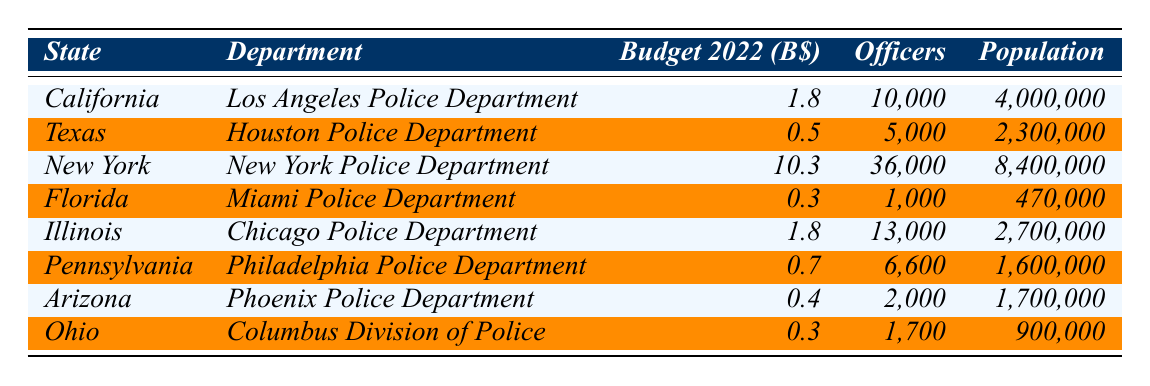What is the budget allocation for the New York Police Department? The budget allocation is directly stated in the table under "Budget 2022" for the New York Police Department, which is 10.3 billion dollars.
Answer: 10.3 billion dollars How many officers does the California Police Department have? The number of officers for the Los Angeles Police Department in California is listed in the table as 10,000.
Answer: 10,000 Which state has the lowest budget allocation for its police department? By comparing the budget allocations from the table, Florida's allocation of 0.3 billion dollars is the lowest.
Answer: Florida What is the total budget allocation for the police departments of California and Illinois combined? The budget for California is 1.8 billion and for Illinois is also 1.8 billion. Adding these gives (1.8 + 1.8) = 3.6 billion dollars.
Answer: 3.6 billion dollars How many officers does the Houston Police Department have compared to the Miami Police Department? The table shows that the Houston Police Department has 5,000 officers while the Miami Police Department has 1,000 officers. Comparatively, Houston has 4,000 more officers than Miami.
Answer: Houston has 4,000 more officers What percentage of the total population served by the police departments listed is served by the New York Police Department? The total population served can be calculated by summing the populations of all listed departments which totals 16,000,000 (4,000,000 + 2,300,000 + 8,400,000 + 470,000 + 2,700,000 + 1,600,000 + 1,700,000 + 900,000). New York serves 8,400,000, the percentage is (8,400,000 / 16,000,000) * 100 = 52.5%.
Answer: 52.5% Which police department serves a higher population: Chicago or Houston? Chicago serves 2,700,000 according to the table, whereas Houston serves 2,300,000; therefore, Chicago serves a higher population.
Answer: Chicago If you combine the number of officers from Arizona and Ohio, how does this compare to the number of officers in Texas? Arizona has 2,000 officers and Ohio has 1,700 officers, summing them gives (2,000 + 1,700) = 3,700. Texas has 5,000 officers; thus, Texas has 1,300 more officers than the combined total.
Answer: Texas has 1,300 more officers Is the total budget allocation for the states of Texas and Florida more than the budget for California? The budget for Texas is 0.5 billion and for Florida is 0.3 billion. When combined (0.5 + 0.3) = 0.8 billion, which is less than California's 1.8 billion budget.
Answer: No, it is not more 